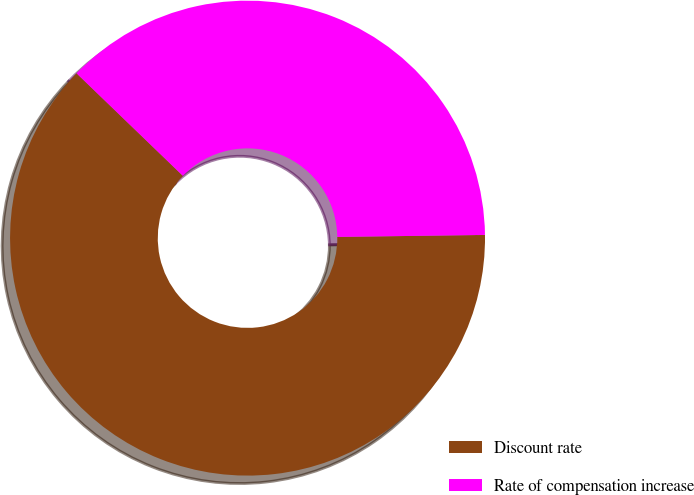<chart> <loc_0><loc_0><loc_500><loc_500><pie_chart><fcel>Discount rate<fcel>Rate of compensation increase<nl><fcel>62.42%<fcel>37.58%<nl></chart> 